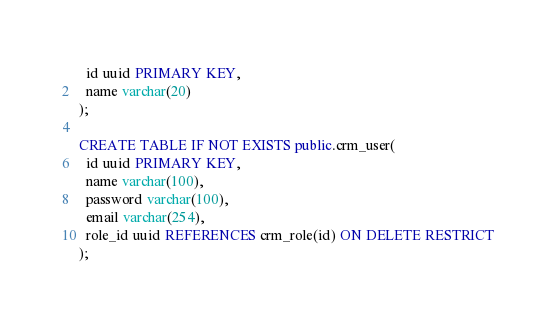<code> <loc_0><loc_0><loc_500><loc_500><_SQL_>  id uuid PRIMARY KEY,
  name varchar(20)
);

CREATE TABLE IF NOT EXISTS public.crm_user(
  id uuid PRIMARY KEY,
  name varchar(100),
  password varchar(100),
  email varchar(254),
  role_id uuid REFERENCES crm_role(id) ON DELETE RESTRICT
);
</code> 